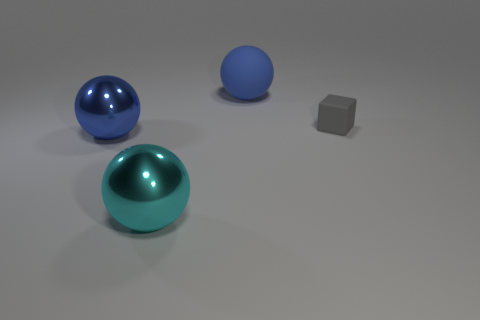Subtract all shiny spheres. How many spheres are left? 1 Add 3 blue rubber cylinders. How many objects exist? 7 Subtract all purple cylinders. How many blue balls are left? 2 Subtract all blue balls. How many balls are left? 1 Subtract all blocks. How many objects are left? 3 Subtract 0 green balls. How many objects are left? 4 Subtract all red blocks. Subtract all purple spheres. How many blocks are left? 1 Subtract all gray things. Subtract all tiny red blocks. How many objects are left? 3 Add 2 large blue things. How many large blue things are left? 4 Add 2 big blue things. How many big blue things exist? 4 